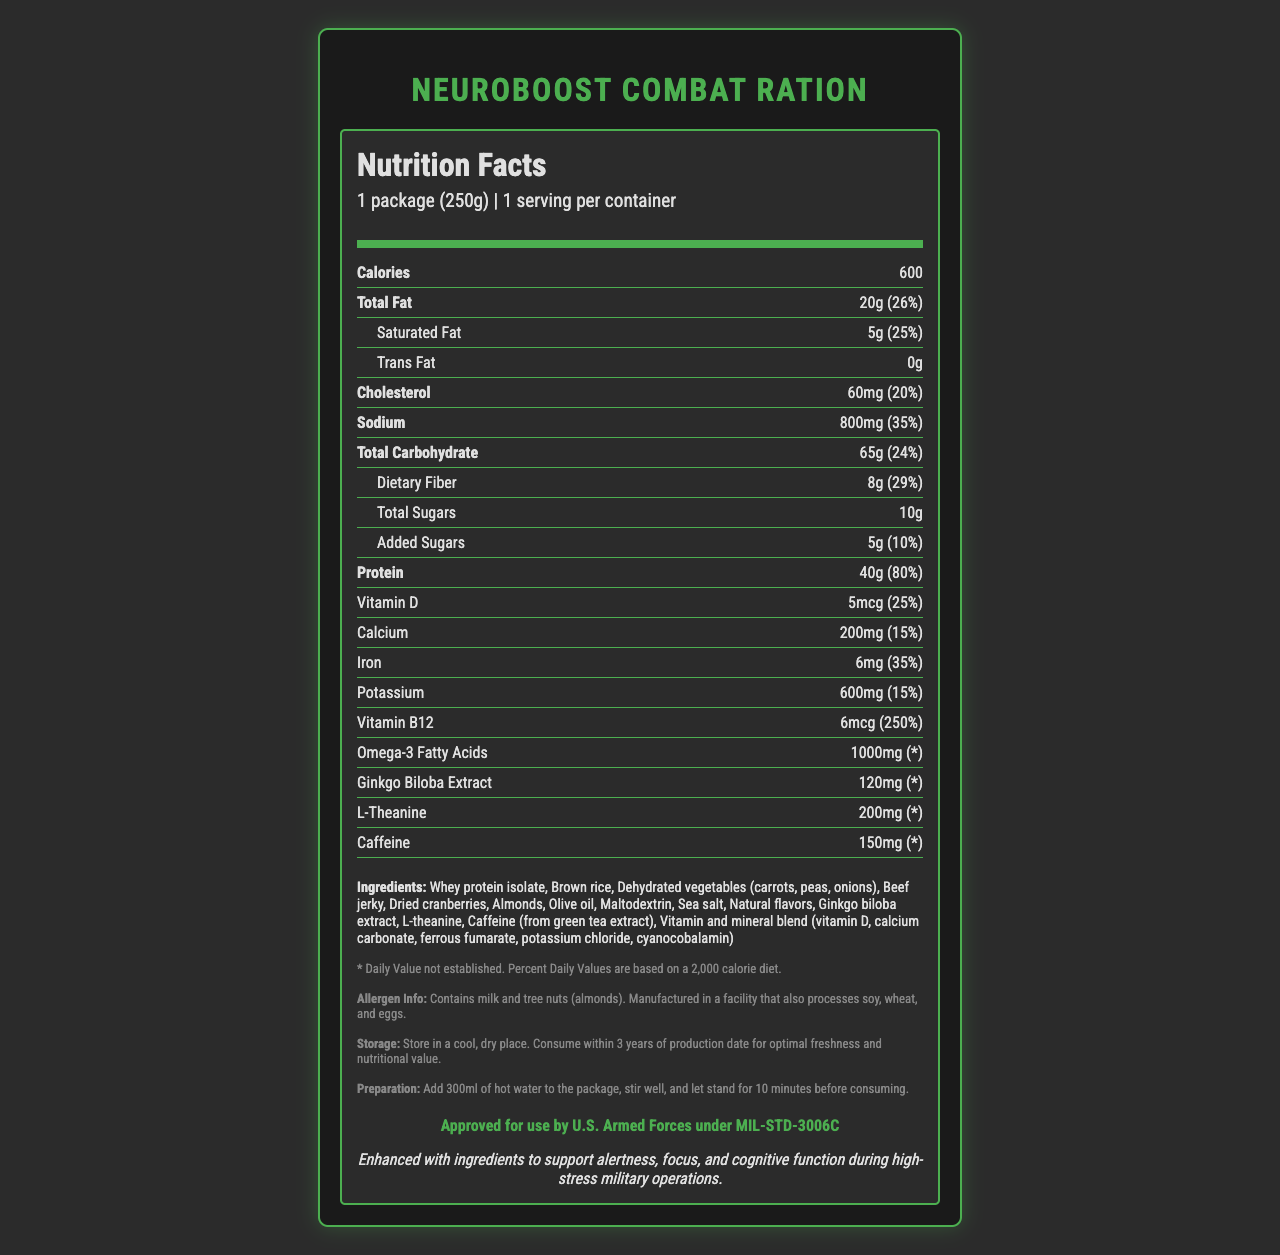what is the serving size? The serving size is clearly listed at the top under the product name with the size specified as 1 package (250g).
Answer: 1 package (250g) how many calories are in one serving? The number of calories for one serving is listed right on top under the "Calories" section.
Answer: 600 what percentage of the daily value for protein does this product provide? Based on the nutrition label, the protein content provides 80% of the daily value.
Answer: 80% which ingredient is listed first in the ingredients list? The ingredients list starts with "Whey protein isolate," indicating it is the most prominent ingredient by weight.
Answer: Whey protein isolate how should this product be prepared? The preparation instructions state to add 300ml of hot water, stir well, and let it stand for 10 minutes before consuming.
Answer: Add 300ml of hot water to the package, stir well, and let stand for 10 minutes before consuming what are the enhanced cognitive performance ingredients? 
A) Whey protein isolate, Brown rice, Sea salt 
B) Ginkgo biloba extract, L-theanine, Caffeine 
C) Dehydrated vegetables, Almonds, Olive oil Ginkgo biloba extract, L-theanine, and Caffeine are the enhanced cognitive performance ingredients listed separately in the nutrition label.
Answer: B how much sodium is in one serving of the NeuroBoost Combat Ration?
A) 400mg
B) 600mg
C) 800mg The nutrition label shows that there are 800mg of sodium per serving.
Answer: C can this product be safely consumed by someone allergic to soy? The allergen info states it contains milk and tree nuts (almonds) and is manufactured in a facility that processes soy. Therefore, it cannot be considered safe for someone allergic to soy.
Answer: No does the product contain trans fat? The nutrition label clearly indicates that the product contains 0g of trans fat.
Answer: No how should the product be stored? The storage instructions specify it should be stored in a cool, dry place and consumed within 3 years for optimal freshness.
Answer: Store in a cool, dry place. Consume within 3 years of production date for optimal freshness and nutritional value. what is the cognitive performance claim made by the product? The cognitive performance claim specifies the product is enhanced with ingredients to support alertness, focus, and cognitive function in high-stress situations.
Answer: Enhanced with ingredients to support alertness, focus, and cognitive function during high-stress military operations how many grams of dietary fiber does the product contain per serving? The nutrition label shows that each serving contains 8g of dietary fiber.
Answer: 8g what is the company that manufactures the NeuroBoost Combat Ration? The manufacturer's name, TacticalNutrition Systems, Inc., is listed at the end of the document.
Answer: TacticalNutrition Systems, Inc. how much omega-3 fatty acids does each serving contain? The nutrition label shows that each serving contains 1000mg of omega-3 fatty acids.
Answer: 1000mg what is the content and daily value percentage of Vitamin D in this product? The nutrition label shows that the product contains 5mcg of Vitamin D, which is 25% of the daily value.
Answer: 5mcg, 25% which nutrient has the highest daily value percentage? A) Vitamin B12 B) Protein C) Sodium Vitamin B12 has the highest daily value percentage at 250%.
Answer: A what is the main idea of the document? The document provides comprehensive information about the nutrition facts, ingredients, preparation, storage, and cognitive performance benefits of the NeuroBoost Combat Ration.
Answer: The document details the nutritional content, ingredients, and specific features of the NeuroBoost Combat Ration, a high-protein military ration that includes ingredients to enhance cognitive performance. is there information about the sourcing of the ingredients? The document lists the ingredients but does not provide information about their sourcing or origin.
Answer: Not enough information 